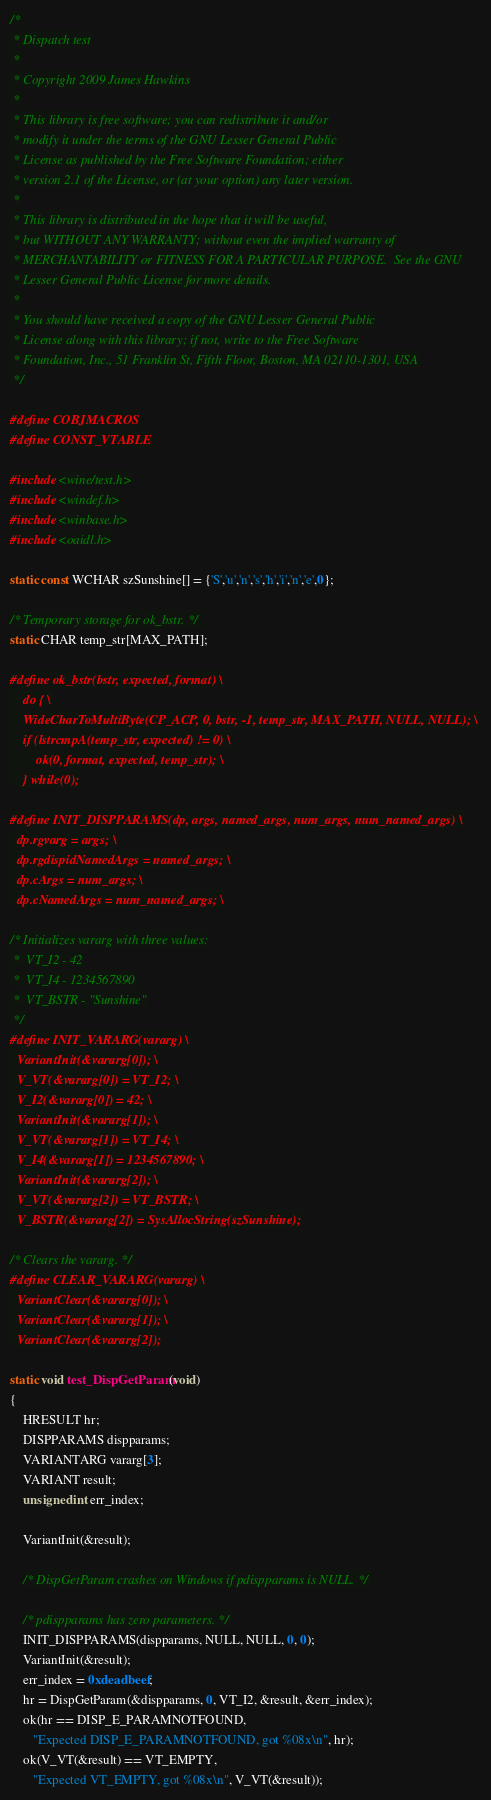Convert code to text. <code><loc_0><loc_0><loc_500><loc_500><_C_>/*
 * Dispatch test
 *
 * Copyright 2009 James Hawkins
 *
 * This library is free software; you can redistribute it and/or
 * modify it under the terms of the GNU Lesser General Public
 * License as published by the Free Software Foundation; either
 * version 2.1 of the License, or (at your option) any later version.
 *
 * This library is distributed in the hope that it will be useful,
 * but WITHOUT ANY WARRANTY; without even the implied warranty of
 * MERCHANTABILITY or FITNESS FOR A PARTICULAR PURPOSE.  See the GNU
 * Lesser General Public License for more details.
 *
 * You should have received a copy of the GNU Lesser General Public
 * License along with this library; if not, write to the Free Software
 * Foundation, Inc., 51 Franklin St, Fifth Floor, Boston, MA 02110-1301, USA
 */

#define COBJMACROS
#define CONST_VTABLE

#include <wine/test.h>
#include <windef.h>
#include <winbase.h>
#include <oaidl.h>

static const WCHAR szSunshine[] = {'S','u','n','s','h','i','n','e',0};

/* Temporary storage for ok_bstr. */
static CHAR temp_str[MAX_PATH];

#define ok_bstr(bstr, expected, format) \
    do { \
    WideCharToMultiByte(CP_ACP, 0, bstr, -1, temp_str, MAX_PATH, NULL, NULL); \
    if (lstrcmpA(temp_str, expected) != 0) \
        ok(0, format, expected, temp_str); \
    } while(0);

#define INIT_DISPPARAMS(dp, args, named_args, num_args, num_named_args) \
  dp.rgvarg = args; \
  dp.rgdispidNamedArgs = named_args; \
  dp.cArgs = num_args; \
  dp.cNamedArgs = num_named_args; \

/* Initializes vararg with three values:
 *  VT_I2 - 42
 *  VT_I4 - 1234567890
 *  VT_BSTR - "Sunshine"
 */
#define INIT_VARARG(vararg) \
  VariantInit(&vararg[0]); \
  V_VT(&vararg[0]) = VT_I2; \
  V_I2(&vararg[0]) = 42; \
  VariantInit(&vararg[1]); \
  V_VT(&vararg[1]) = VT_I4; \
  V_I4(&vararg[1]) = 1234567890; \
  VariantInit(&vararg[2]); \
  V_VT(&vararg[2]) = VT_BSTR; \
  V_BSTR(&vararg[2]) = SysAllocString(szSunshine);

/* Clears the vararg. */
#define CLEAR_VARARG(vararg) \
  VariantClear(&vararg[0]); \
  VariantClear(&vararg[1]); \
  VariantClear(&vararg[2]);

static void test_DispGetParam(void)
{
    HRESULT hr;
    DISPPARAMS dispparams;
    VARIANTARG vararg[3];
    VARIANT result;
    unsigned int err_index;

    VariantInit(&result);

    /* DispGetParam crashes on Windows if pdispparams is NULL. */

    /* pdispparams has zero parameters. */
    INIT_DISPPARAMS(dispparams, NULL, NULL, 0, 0);
    VariantInit(&result);
    err_index = 0xdeadbeef;
    hr = DispGetParam(&dispparams, 0, VT_I2, &result, &err_index);
    ok(hr == DISP_E_PARAMNOTFOUND,
       "Expected DISP_E_PARAMNOTFOUND, got %08x\n", hr);
    ok(V_VT(&result) == VT_EMPTY,
       "Expected VT_EMPTY, got %08x\n", V_VT(&result));</code> 